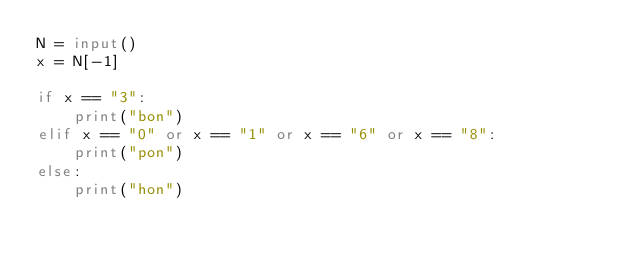Convert code to text. <code><loc_0><loc_0><loc_500><loc_500><_Python_>N = input()
x = N[-1]

if x == "3":
    print("bon")
elif x == "0" or x == "1" or x == "6" or x == "8":
    print("pon")
else:
    print("hon")


</code> 